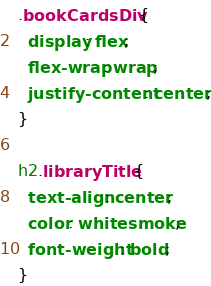<code> <loc_0><loc_0><loc_500><loc_500><_CSS_>.bookCardsDiv {
  display: flex;
  flex-wrap: wrap;
  justify-content: center;
}

h2.libraryTitle {
  text-align: center;
  color: whitesmoke;
  font-weight: bold;
}
</code> 